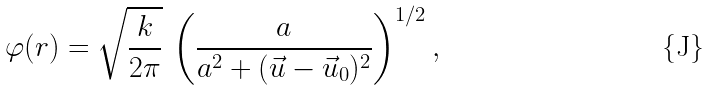Convert formula to latex. <formula><loc_0><loc_0><loc_500><loc_500>\varphi ( r ) = \sqrt { \frac { k } { 2 \pi } } \, \left ( \frac { a } { a ^ { 2 } + ( \vec { u } - \vec { u } _ { 0 } ) ^ { 2 } } \right ) ^ { 1 / 2 } ,</formula> 